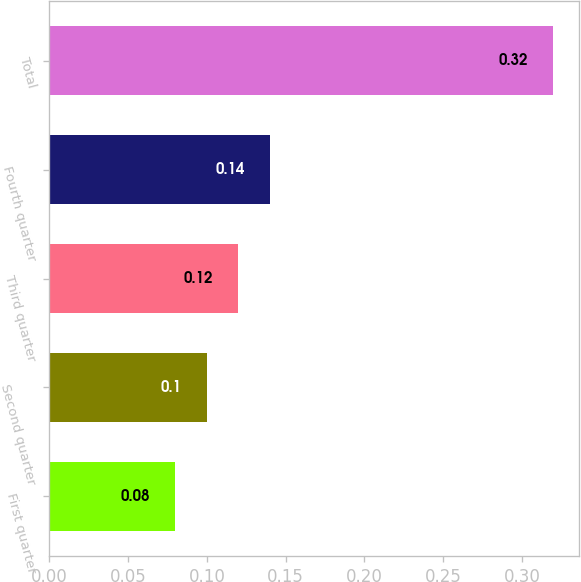<chart> <loc_0><loc_0><loc_500><loc_500><bar_chart><fcel>First quarter<fcel>Second quarter<fcel>Third quarter<fcel>Fourth quarter<fcel>Total<nl><fcel>0.08<fcel>0.1<fcel>0.12<fcel>0.14<fcel>0.32<nl></chart> 